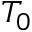Convert formula to latex. <formula><loc_0><loc_0><loc_500><loc_500>T _ { 0 }</formula> 